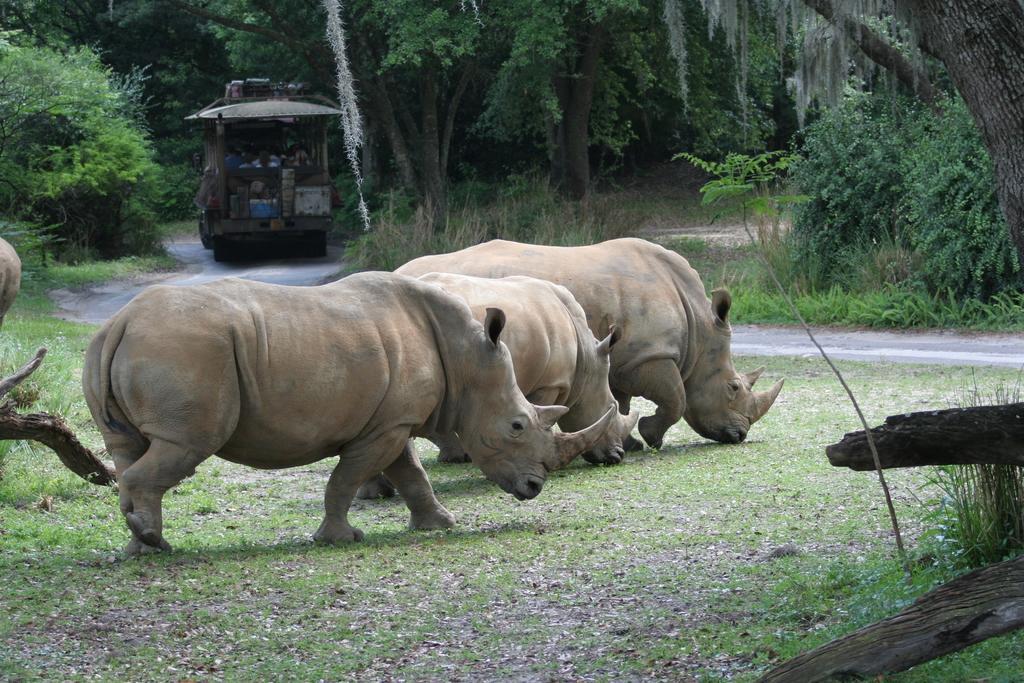Please provide a concise description of this image. In this picture we can see rhinoceros on the path and behind the rhinoceros there is a vehicle with some people and behind the vehicle there are trees 